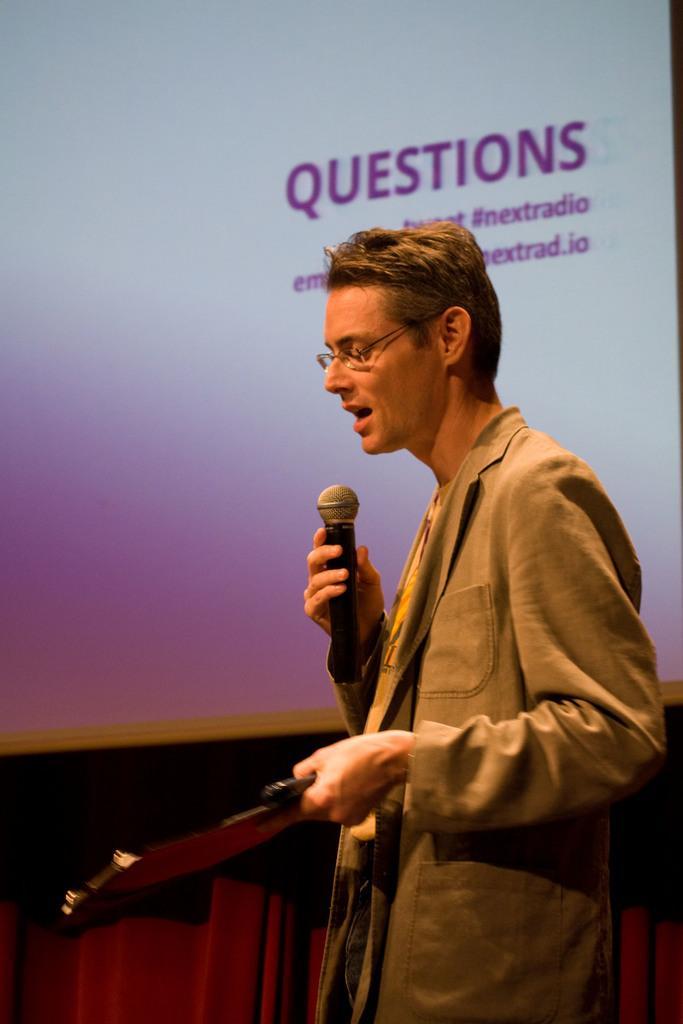Describe this image in one or two sentences. In this image I can see a man and he is holding a mic in his hand. 